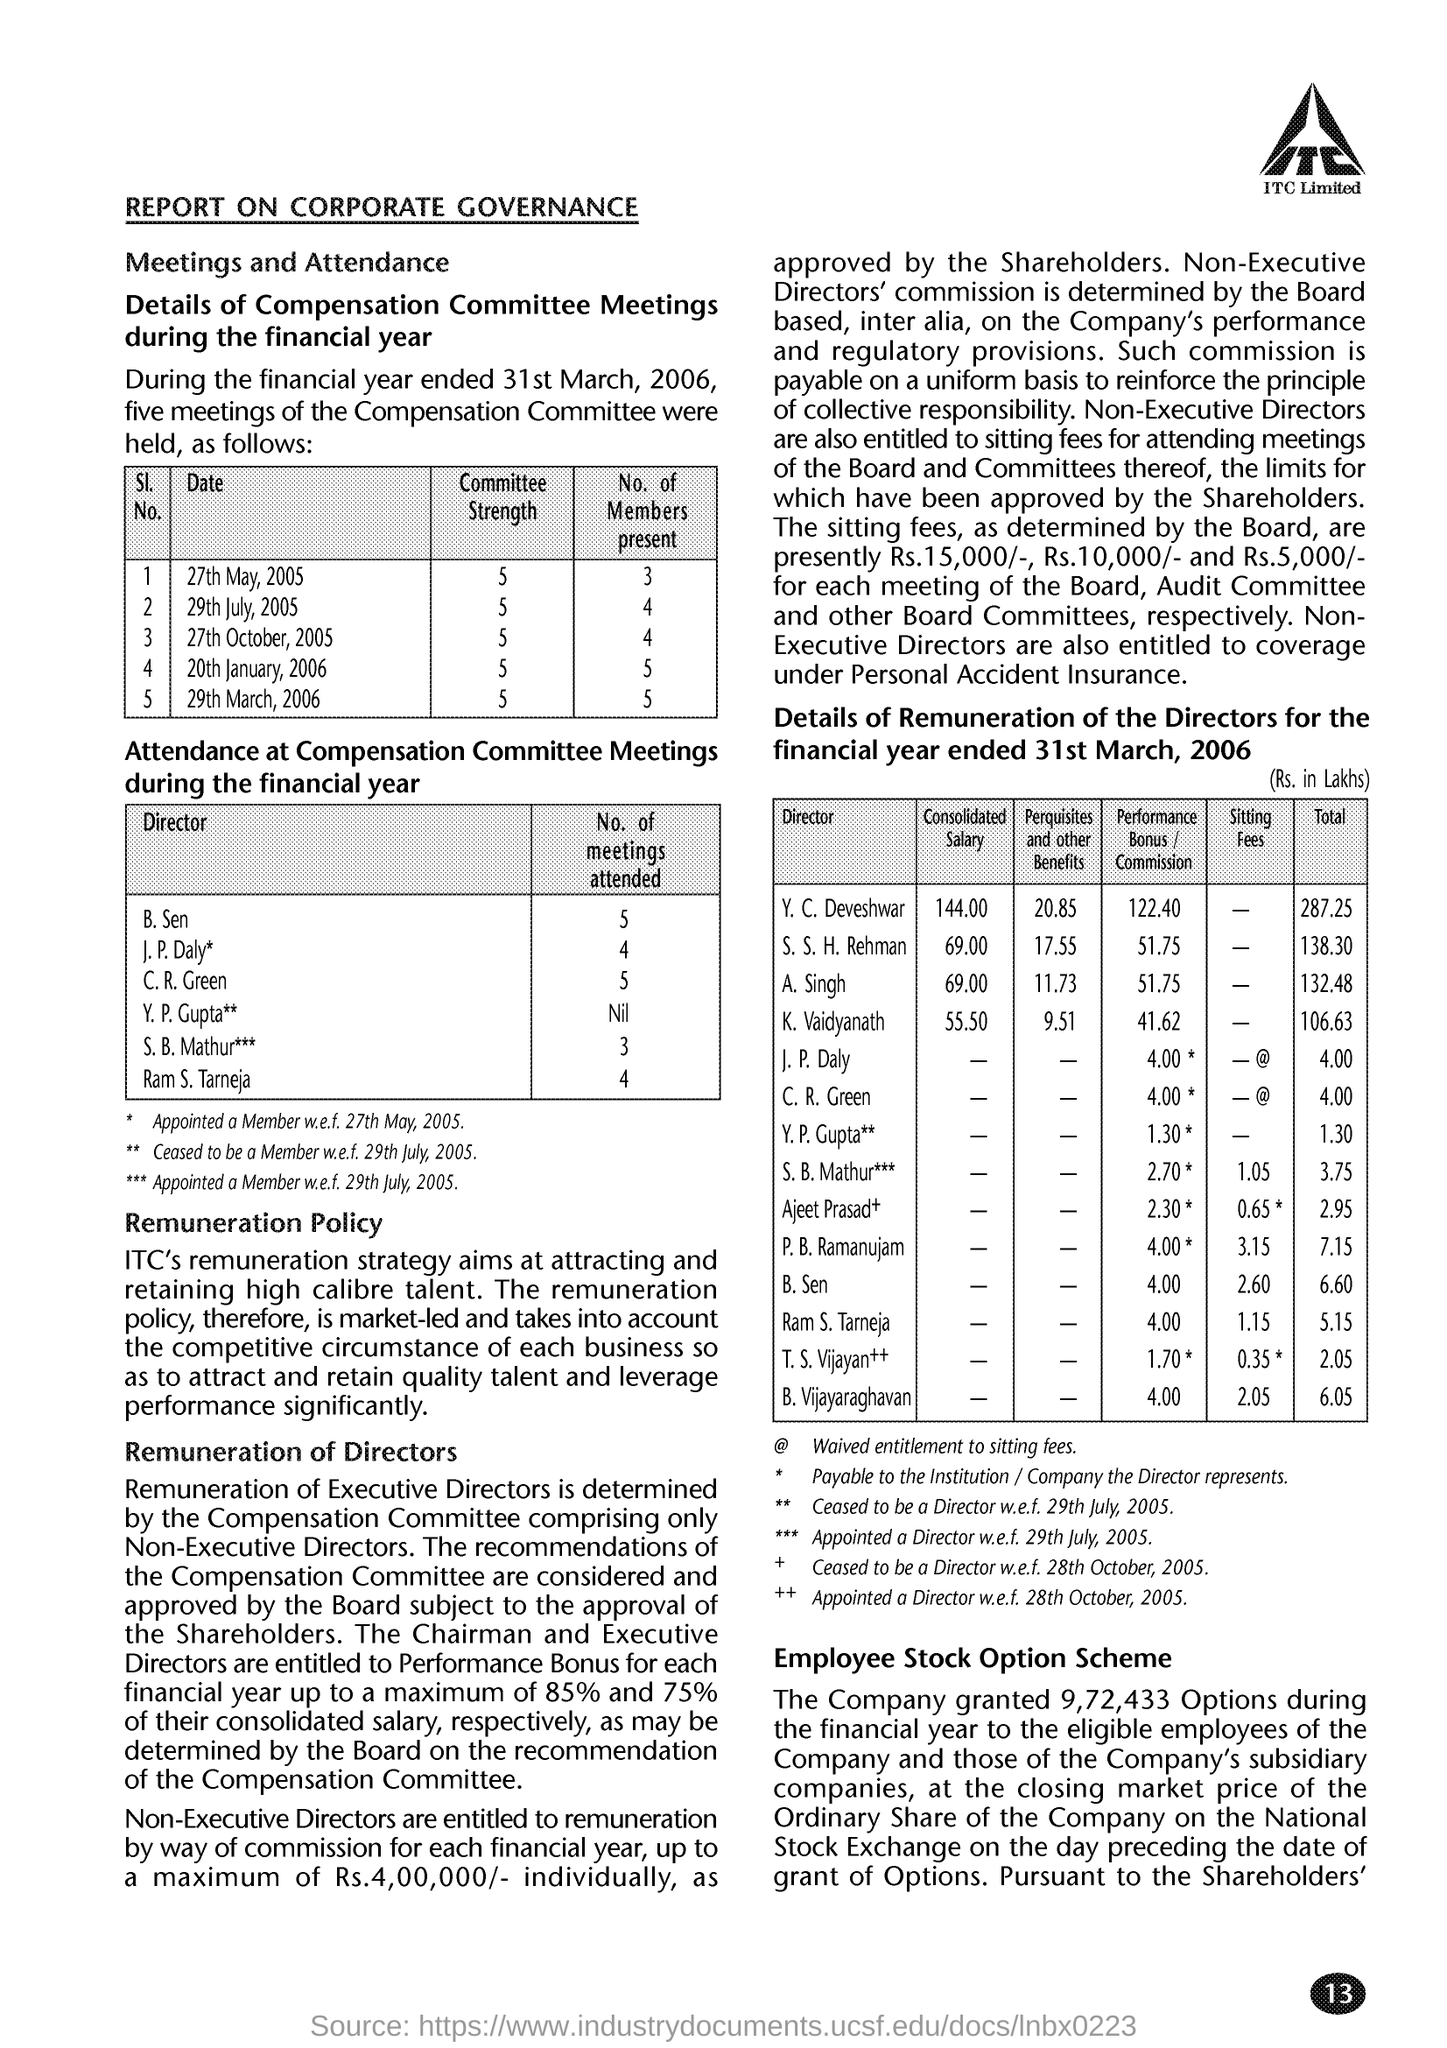The report is on what topic?
Make the answer very short. Corporate Governance. What aims at attracting and retaining high calibre talent?
Keep it short and to the point. ITC's remuneration strategy. 